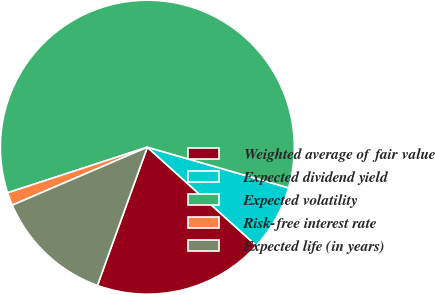Convert chart. <chart><loc_0><loc_0><loc_500><loc_500><pie_chart><fcel>Weighted average of fair value<fcel>Expected dividend yield<fcel>Expected volatility<fcel>Risk-free interest rate<fcel>Expected life (in years)<nl><fcel>18.83%<fcel>7.23%<fcel>59.48%<fcel>1.43%<fcel>13.03%<nl></chart> 